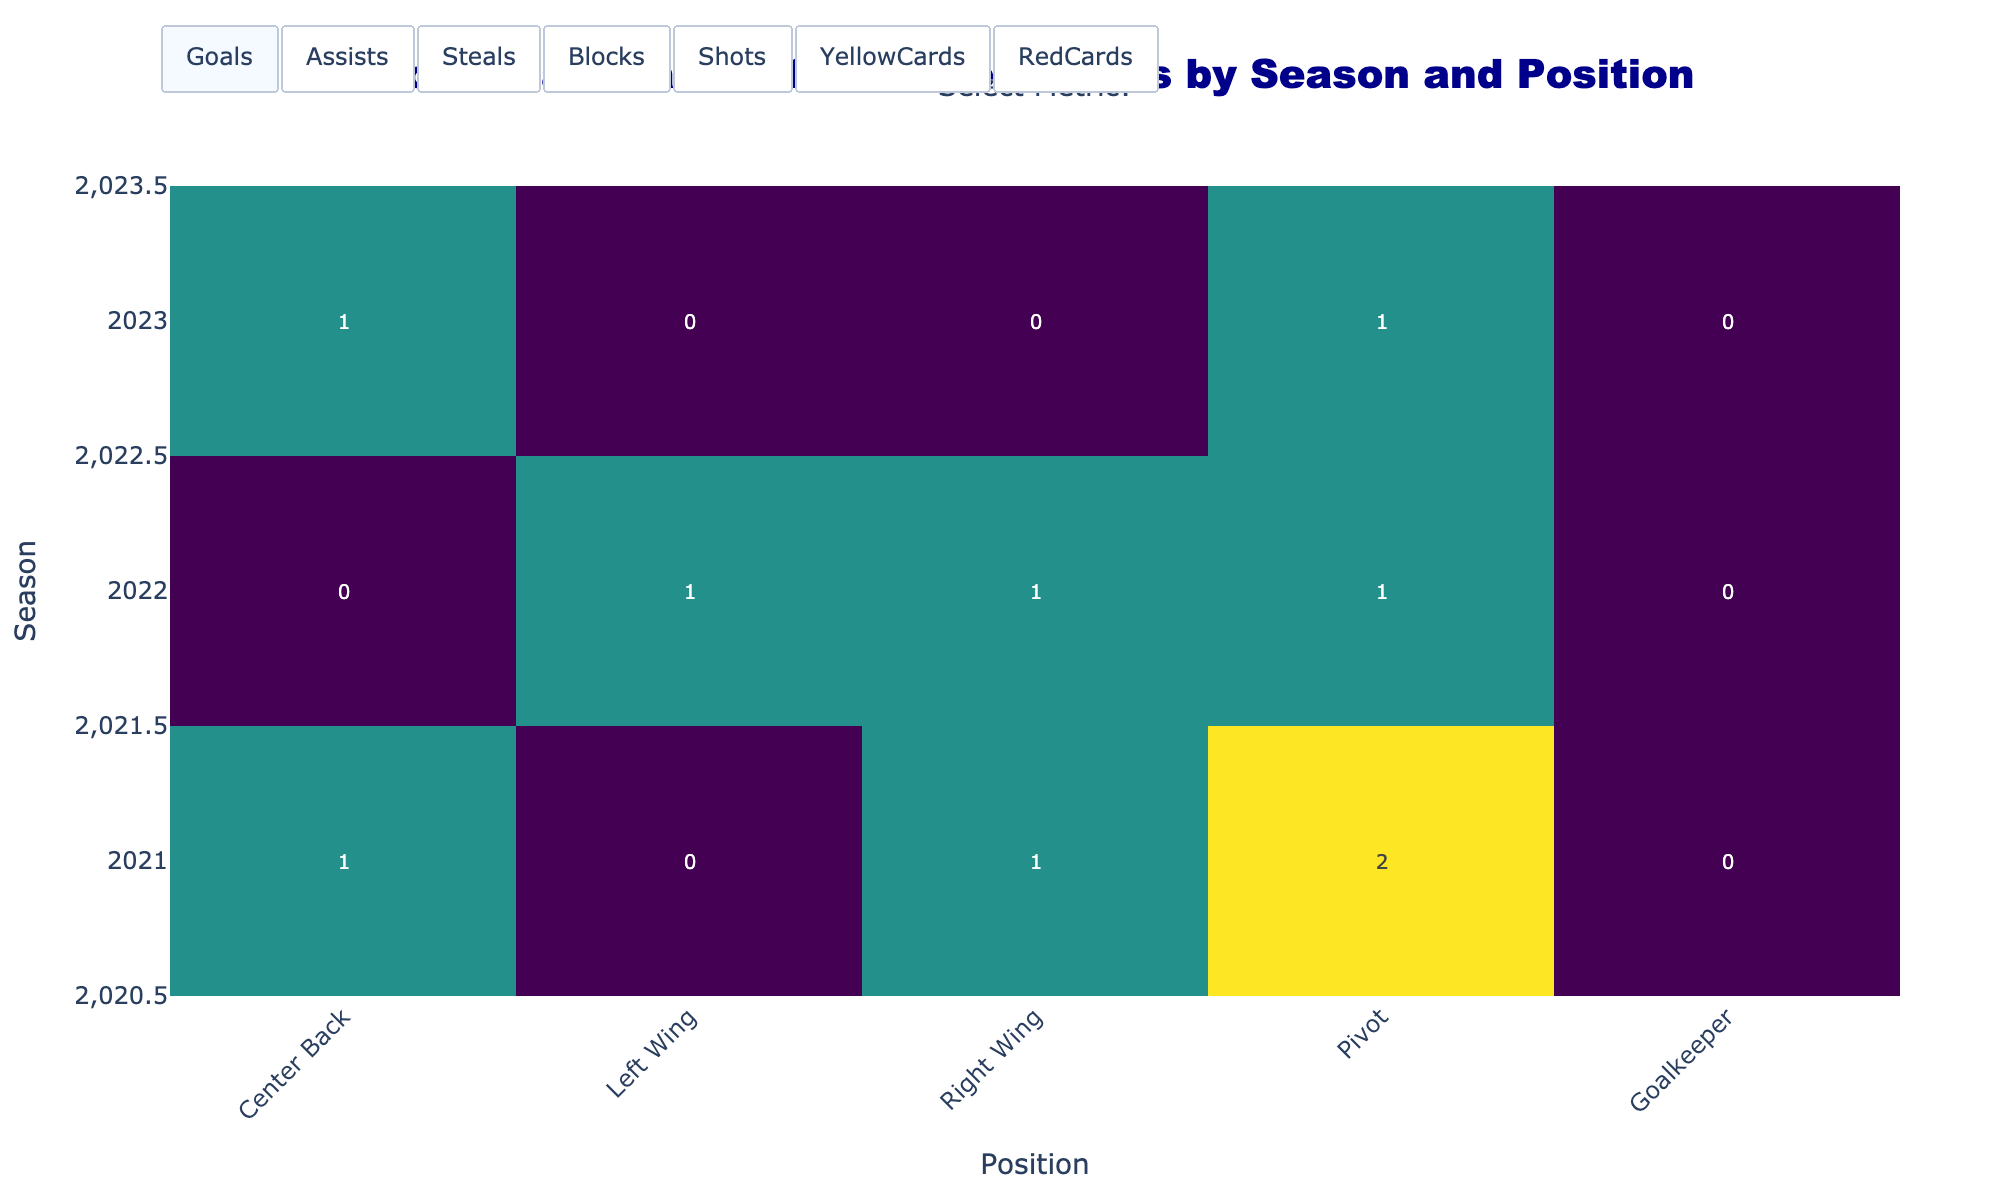Which season did Pedro Cruz score the most goals? Examine the heatmap to identify the season and position where Pedro Cruz's goals are highest. Pick 'Center Back' under 'Goals' metric and compare values across seasons. Pedro Cruz scored the most goals in the 2023 season.
Answer: 2023 How many steals did Victor Iturriza have in 2022? Look at the heatmap displaying steals for the Pivot position. In the 2022 row under Pivot, the heatmap shows 32 steals.
Answer: 32 Which position had the highest number of blocks in 2023? Review the heatmap for blocks in the 2023 season. Compare the values across all positions. Victor Iturriza at Pivot had the highest number of blocks with 25.
Answer: Pivot What is the difference in the number of yellow cards between Antonio Areia in 2021 and 2022? Check the yellow cards for Antonio Areia (Left Wing) in both 2021 and 2022. In 2021 it's 5 and in 2022 it's 3. Difference is 5 - 3 = 2.
Answer: 2 Who had more assists in 2022, Diogo Branquinho or Pedro Cruz? Compare assists in the year 2022 for Diogo Branquinho (Right Wing) and Pedro Cruz (Center Back). Diogo Branquinho has 28 and Pedro Cruz has 50 assists. Thus, Pedro Cruz had more assists.
Answer: Pedro Cruz What is the sum of goals scored by FC Porto handball players in all positions in 2023? Review the heatmap for goals in 2023 and sum values across all positions: 140 (Center Back) + 105 (Left Wing) + 120 (Right Wing) + 95 (Pivot) + 0 (Goalkeeper) = 460
Answer: 460 Which player had the least number of red cards in 2021? Look at the heatmap for red cards in 2021. Review all positions and note the red card values. Alfredo Quintana, the Goalkeeper, had 0 red cards, which is the least.
Answer: Alfredo Quintana What is the average number of shots taken by Diogo Branquinho over the three seasons? Check the shots for Right Wing (Diogo Branquinho) across 2021, 2022, and 2023. The values are 210, 220, and 230. Average: (210 + 220 + 230) / 3 = 220.
Answer: 220 Who had more blocks in 2022, Pedro Cruz or Diogo Branquinho? Compare the number of blocks in 2022 for Pedro Cruz (Center Back) and Diogo Branquinho (Right Wing). Diogo Branquinho had 10, and Pedro Cruz had 6. Branquinho had more blocks.
Answer: Diogo Branquinho 